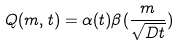<formula> <loc_0><loc_0><loc_500><loc_500>Q ( m , t ) = \alpha ( t ) \beta ( \frac { m } { \sqrt { D t } } )</formula> 